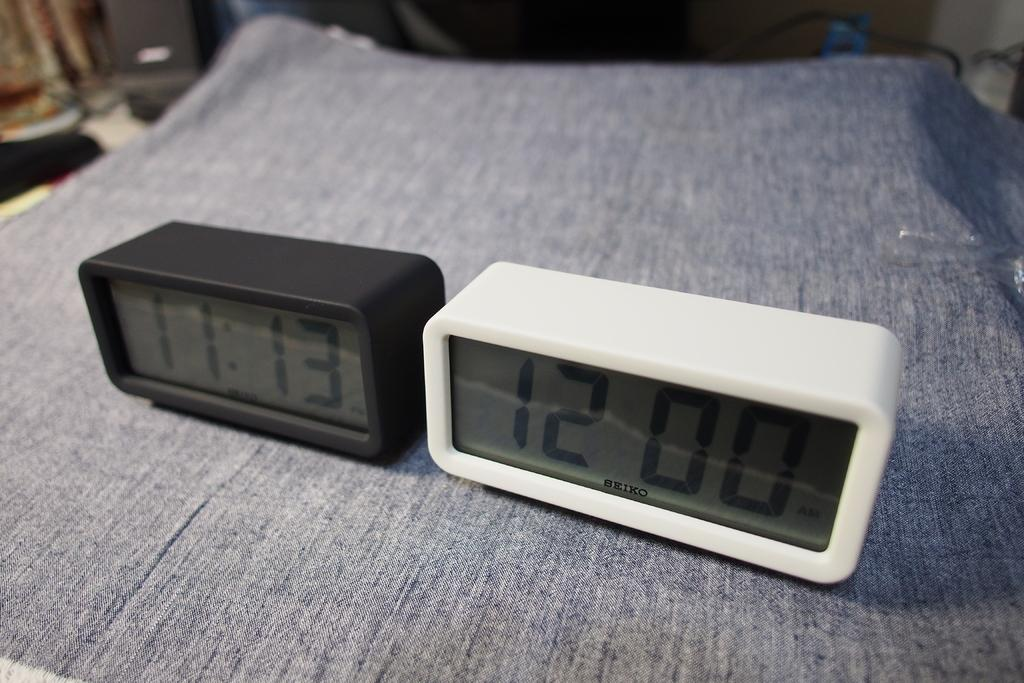<image>
Write a terse but informative summary of the picture. Black and white digital clocks with the white clock showing 12. 